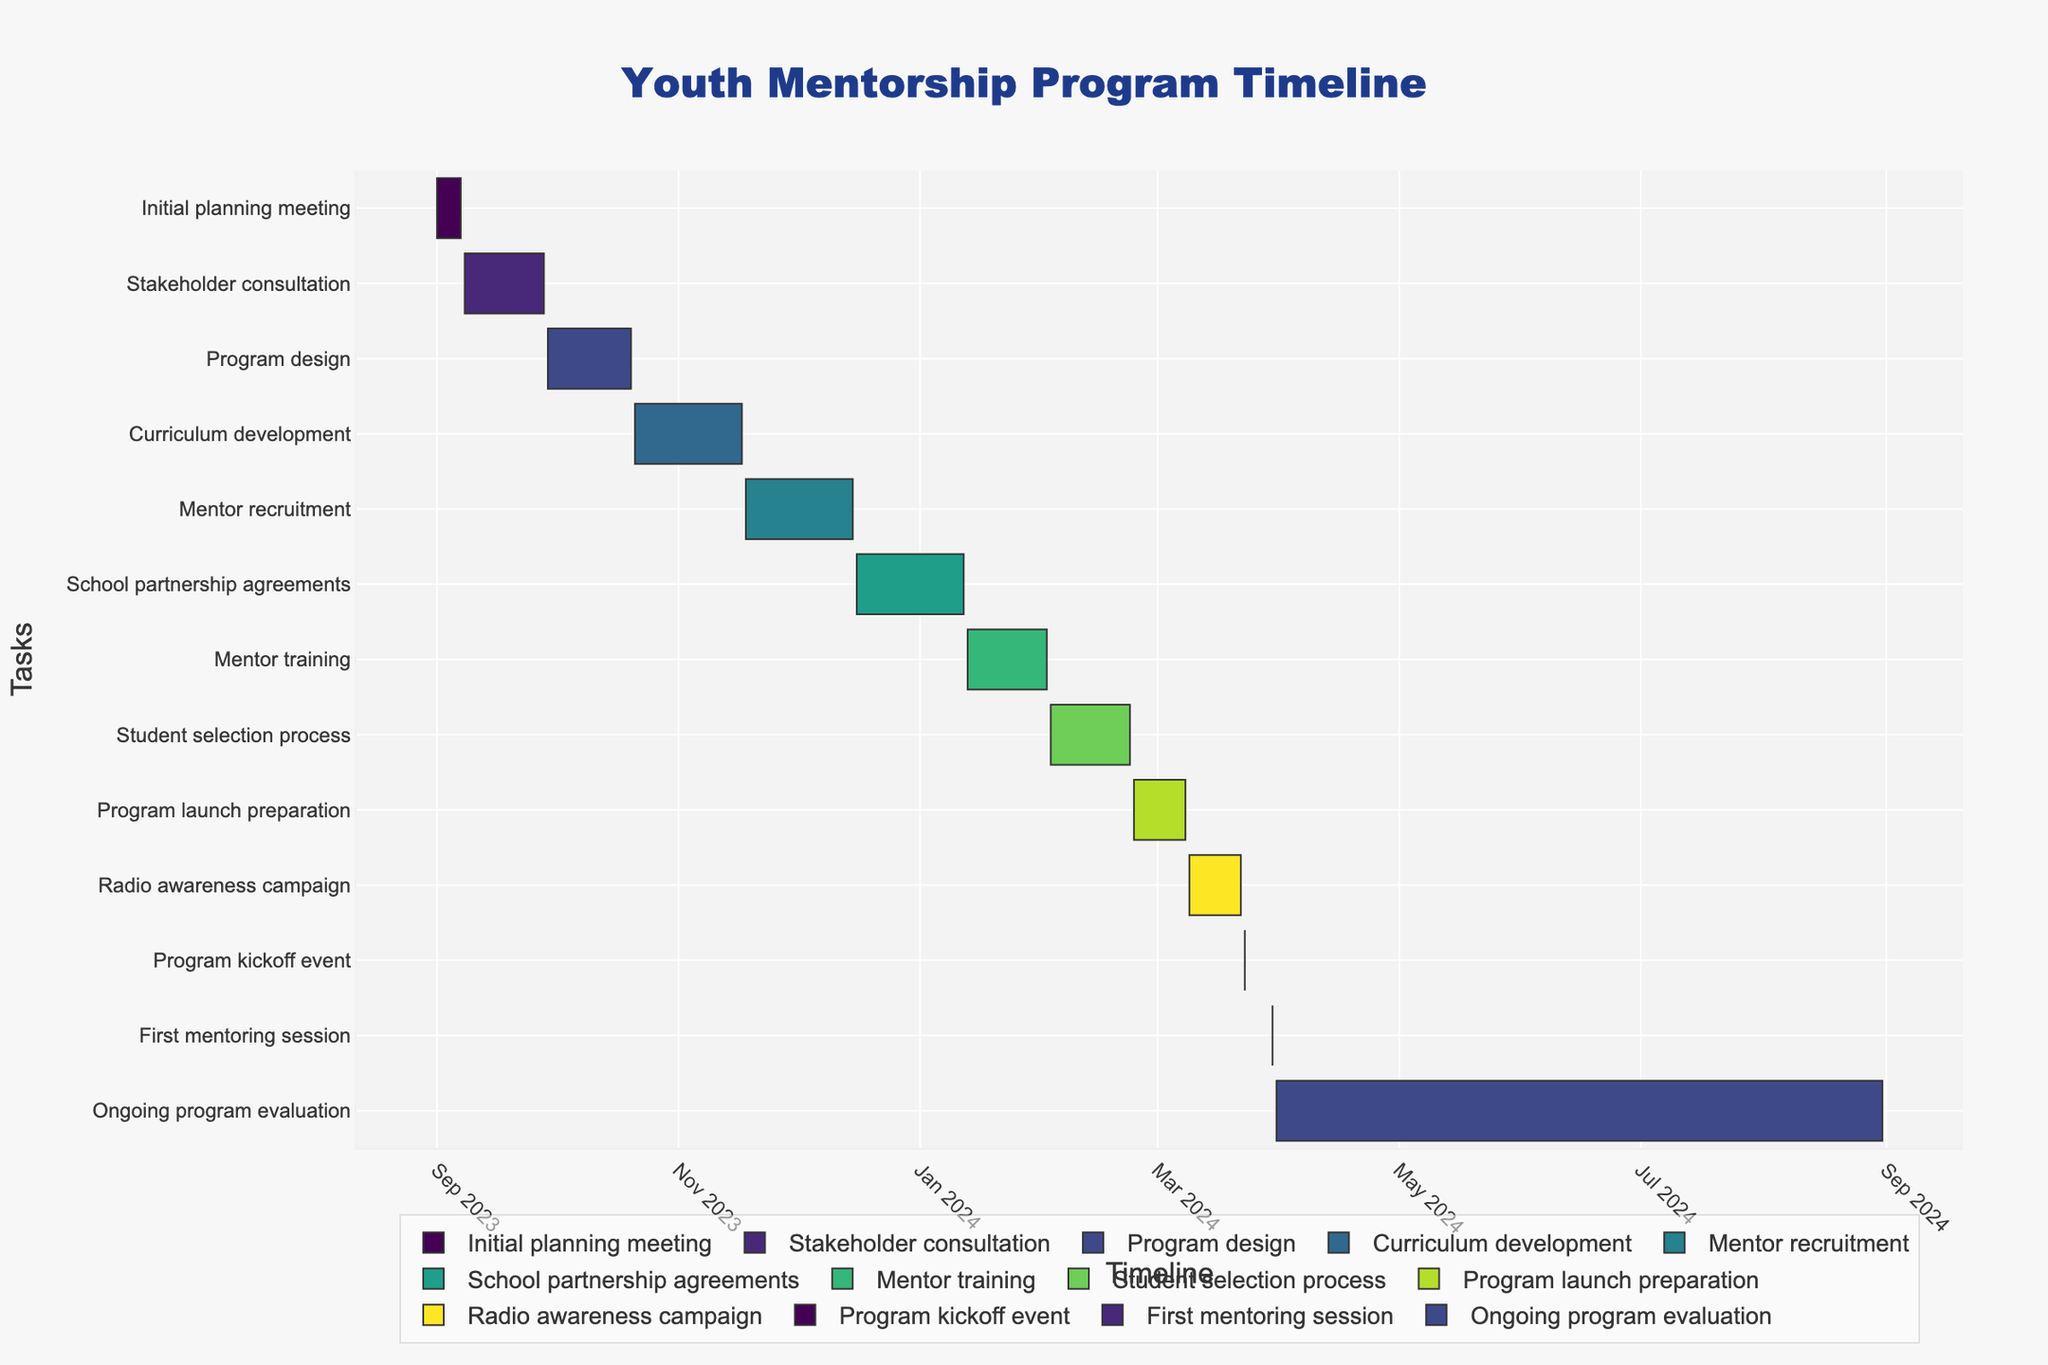What is the title of the Gantt Chart? The title is the text that appears at the top of a chart and provides an indication of what the chart is about. According to the code, the title for this Gantt Chart is "Youth Mentorship Program Timeline".
Answer: Youth Mentorship Program Timeline When does the 'Mentor recruitment' task start and end? The start and end dates of a task are indicated visually on a Gantt chart by the beginning and end of the respective bars. For 'Mentor recruitment', it starts on 2023-11-18 and ends on 2023-12-15.
Answer: 2023-11-18 to 2023-12-15 Which task has the shortest duration, and how long is it? By examining the length of the bars, the task with the shortest duration is 'Program kickoff event', lasting only one day on 2024-03-23.
Answer: Program kickoff event, 1 day What is the overall timeline for the mentorship program from the initial planning meeting to the first mentoring session? To find the overall timeline, we look at the start date of the first task ('Initial planning meeting' on 2023-09-01) and the end date of the 'First mentoring session' (2024-03-30).
Answer: 2023-09-01 to 2024-03-30 How many days are planned between the 'Stakeholder consultation' and 'Program design' tasks? The 'Stakeholder consultation' task ends on 2023-09-28 and 'Program design' starts on 2023-09-29. The number of days between them is simply the difference between these two dates, which is 1 day.
Answer: 1 day Which task takes the longest time to complete, and what is its duration? To determine the task with the longest duration, we identify the longest bar on the Gantt chart, which is 'Ongoing program evaluation' with a duration from 2024-03-31 to 2024-08-31. The duration is calculated as the difference between these dates, which is 154 days.
Answer: Ongoing program evaluation, 154 days What tasks are scheduled to occur simultaneously? Tasks that overlap on the timeline have some periods where they are scheduled simultaneously. Identify overlapping bars on the Gantt chart. 'Student selection process' (2024-02-03 to 2024-02-23) and 'Mentor training' (2024-01-13 to 2024-02-02) overlap.
Answer: Mentor training and Student selection process When does the 'Radio awareness campaign' end, and when does the 'Program kickoff event' begin? The 'Radio awareness campaign' ends on 2024-03-22 and the 'Program kickoff event' begins on 2024-03-23.
Answer: 2024-03-22 and 2024-03-23 How long after the 'Program launch preparation' does the 'Program kickoff event' occur? 'Program launch preparation' ends on 2024-03-08 and 'Program kickoff event' happens on 2024-03-23. The difference between these dates is 15 days.
Answer: 15 days 